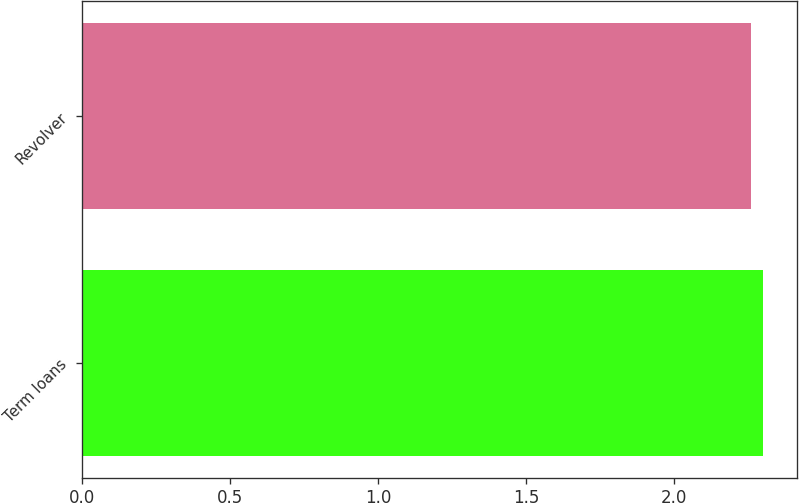Convert chart to OTSL. <chart><loc_0><loc_0><loc_500><loc_500><bar_chart><fcel>Term loans<fcel>Revolver<nl><fcel>2.3<fcel>2.26<nl></chart> 